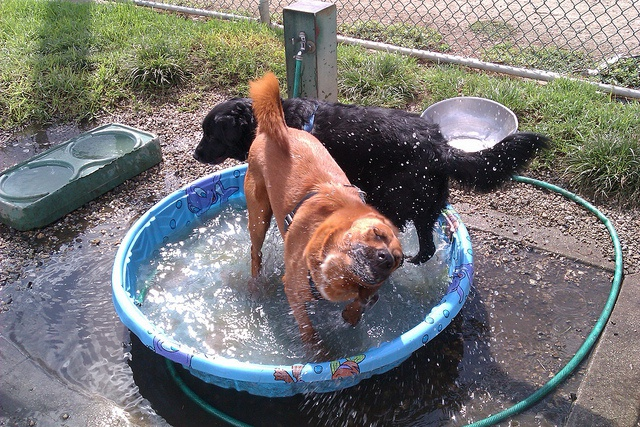Describe the objects in this image and their specific colors. I can see dog in tan, brown, salmon, and gray tones, dog in tan, brown, salmon, and maroon tones, dog in tan, black, gray, and darkgray tones, and bowl in tan, lavender, and darkgray tones in this image. 